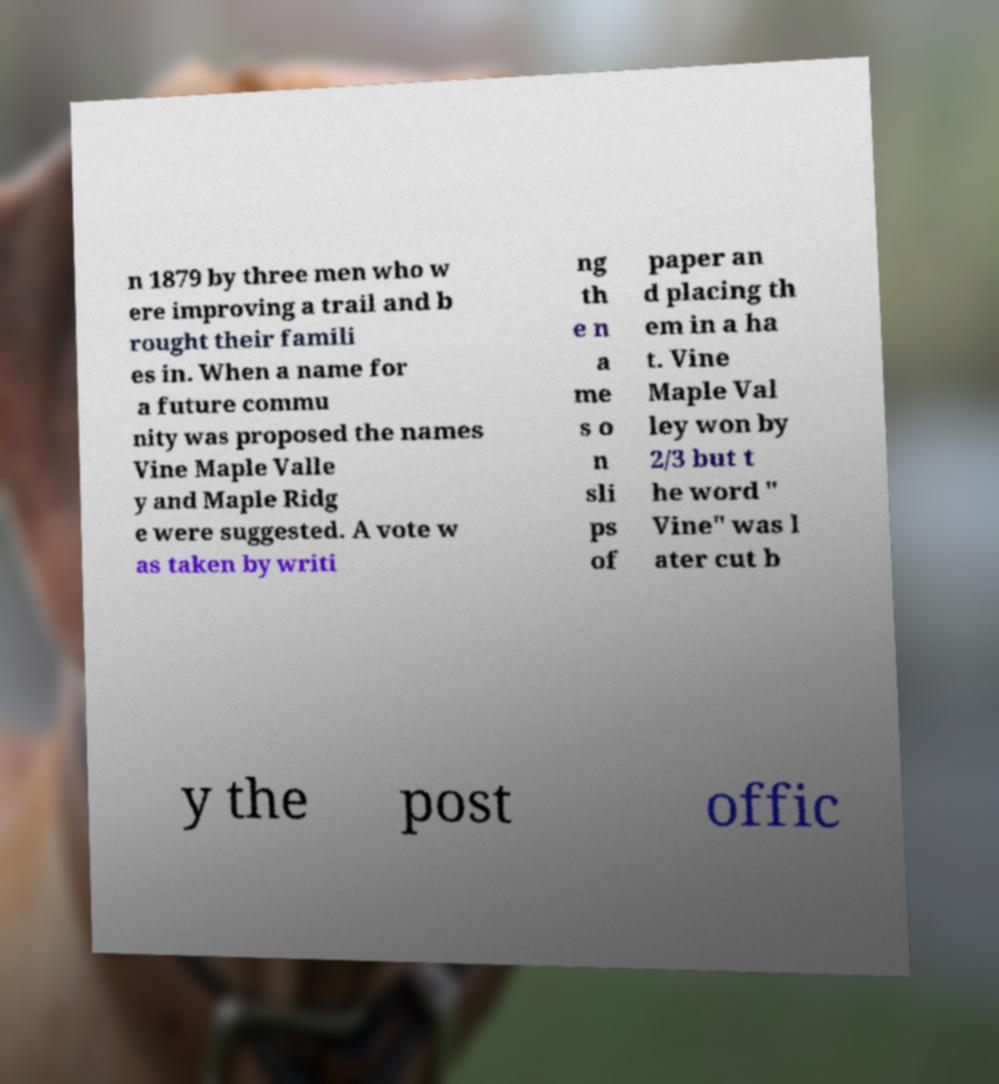Please identify and transcribe the text found in this image. n 1879 by three men who w ere improving a trail and b rought their famili es in. When a name for a future commu nity was proposed the names Vine Maple Valle y and Maple Ridg e were suggested. A vote w as taken by writi ng th e n a me s o n sli ps of paper an d placing th em in a ha t. Vine Maple Val ley won by 2/3 but t he word " Vine" was l ater cut b y the post offic 